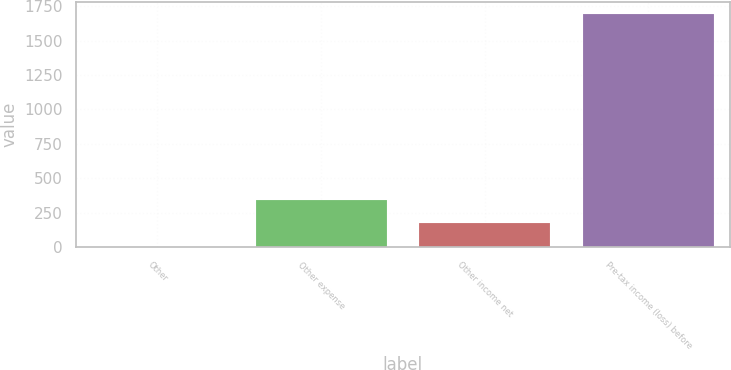<chart> <loc_0><loc_0><loc_500><loc_500><bar_chart><fcel>Other<fcel>Other expense<fcel>Other income net<fcel>Pre-tax income (loss) before<nl><fcel>4<fcel>342<fcel>173<fcel>1694<nl></chart> 